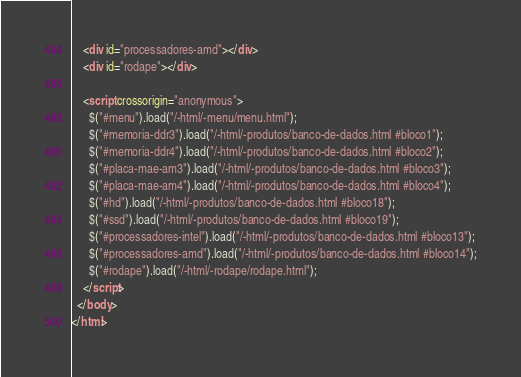Convert code to text. <code><loc_0><loc_0><loc_500><loc_500><_HTML_>    <div id="processadores-amd"></div>
    <div id="rodape"></div>

    <script crossorigin="anonymous">
      $("#menu").load("/-html/-menu/menu.html");
      $("#memoria-ddr3").load("/-html/-produtos/banco-de-dados.html #bloco1");
      $("#memoria-ddr4").load("/-html/-produtos/banco-de-dados.html #bloco2");
      $("#placa-mae-am3").load("/-html/-produtos/banco-de-dados.html #bloco3");
      $("#placa-mae-am4").load("/-html/-produtos/banco-de-dados.html #bloco4");
      $("#hd").load("/-html/-produtos/banco-de-dados.html #bloco18");
      $("#ssd").load("/-html/-produtos/banco-de-dados.html #bloco19");
      $("#processadores-intel").load("/-html/-produtos/banco-de-dados.html #bloco13");
      $("#processadores-amd").load("/-html/-produtos/banco-de-dados.html #bloco14");
      $("#rodape").load("/-html/-rodape/rodape.html");
    </script>
  </body>
</html>
</code> 